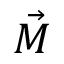<formula> <loc_0><loc_0><loc_500><loc_500>\vec { M }</formula> 